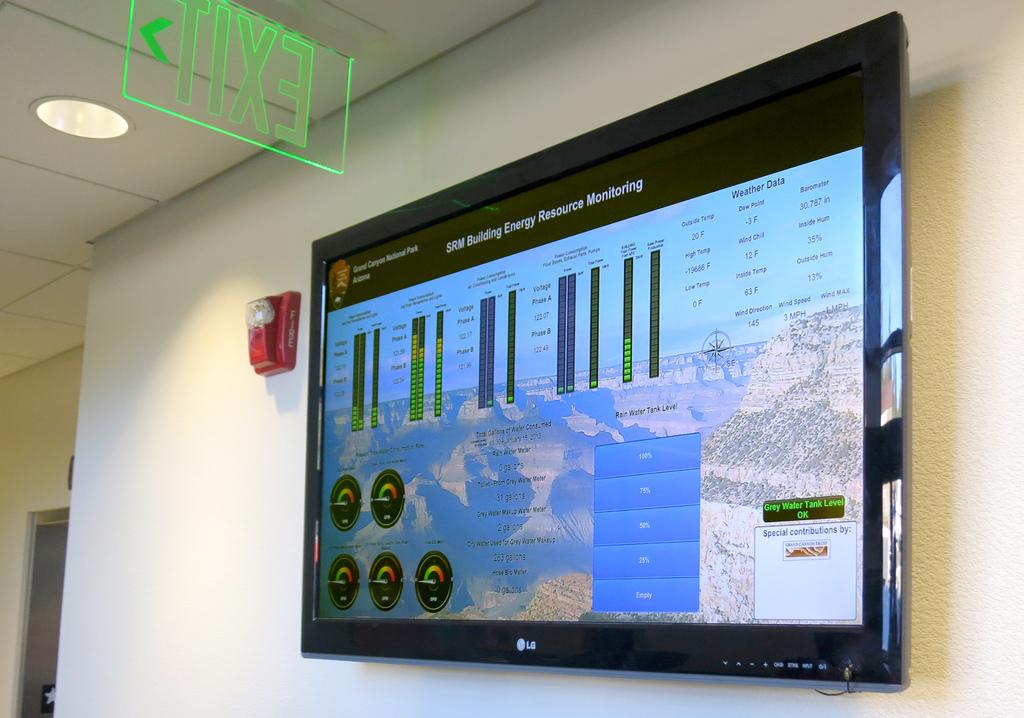Who makes the tv set?
Offer a terse response. Lg. What sign is in green?
Provide a succinct answer. Exit. 